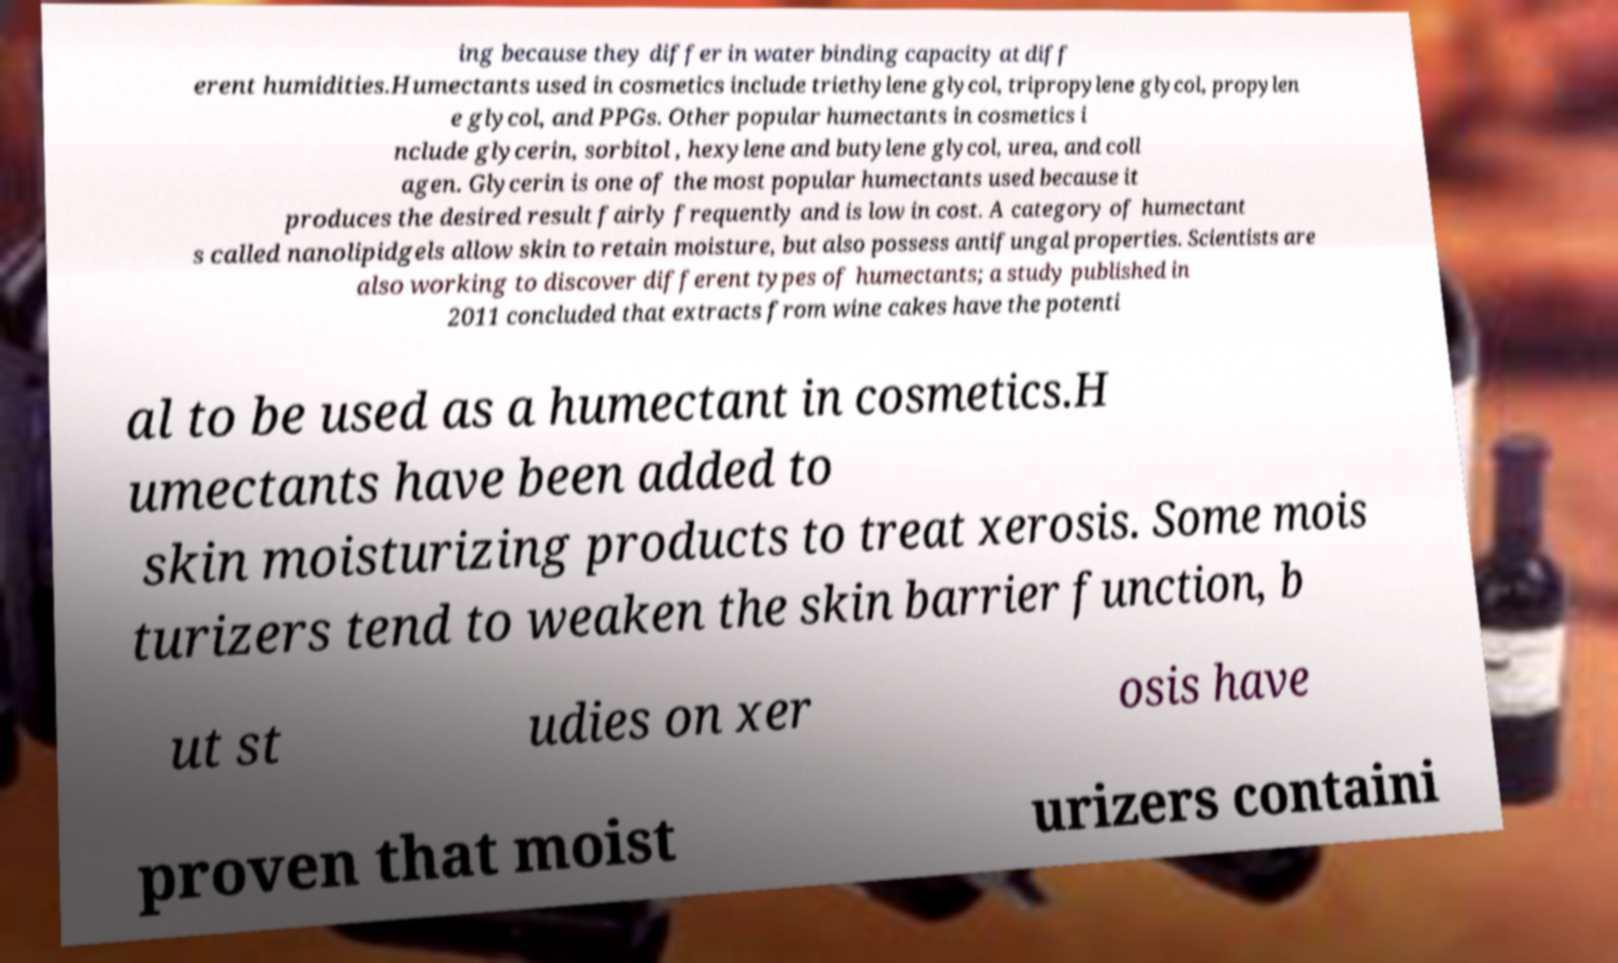There's text embedded in this image that I need extracted. Can you transcribe it verbatim? ing because they differ in water binding capacity at diff erent humidities.Humectants used in cosmetics include triethylene glycol, tripropylene glycol, propylen e glycol, and PPGs. Other popular humectants in cosmetics i nclude glycerin, sorbitol , hexylene and butylene glycol, urea, and coll agen. Glycerin is one of the most popular humectants used because it produces the desired result fairly frequently and is low in cost. A category of humectant s called nanolipidgels allow skin to retain moisture, but also possess antifungal properties. Scientists are also working to discover different types of humectants; a study published in 2011 concluded that extracts from wine cakes have the potenti al to be used as a humectant in cosmetics.H umectants have been added to skin moisturizing products to treat xerosis. Some mois turizers tend to weaken the skin barrier function, b ut st udies on xer osis have proven that moist urizers containi 